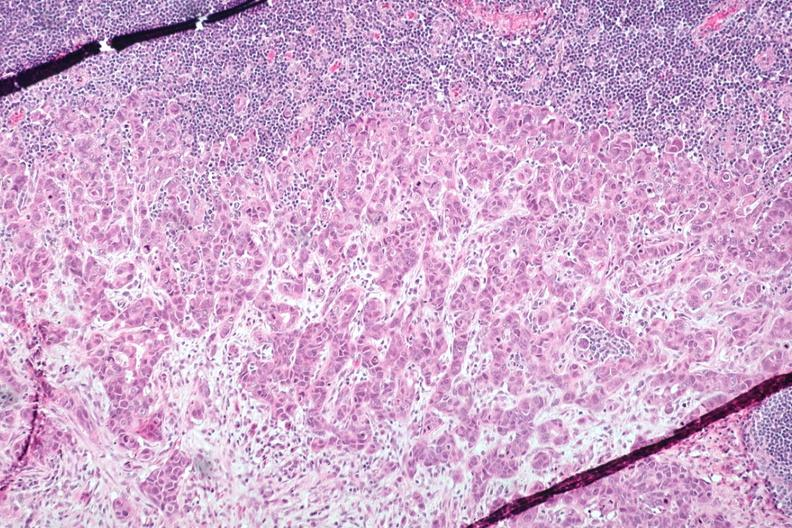s metastatic adenocarcinoma present?
Answer the question using a single word or phrase. Yes 